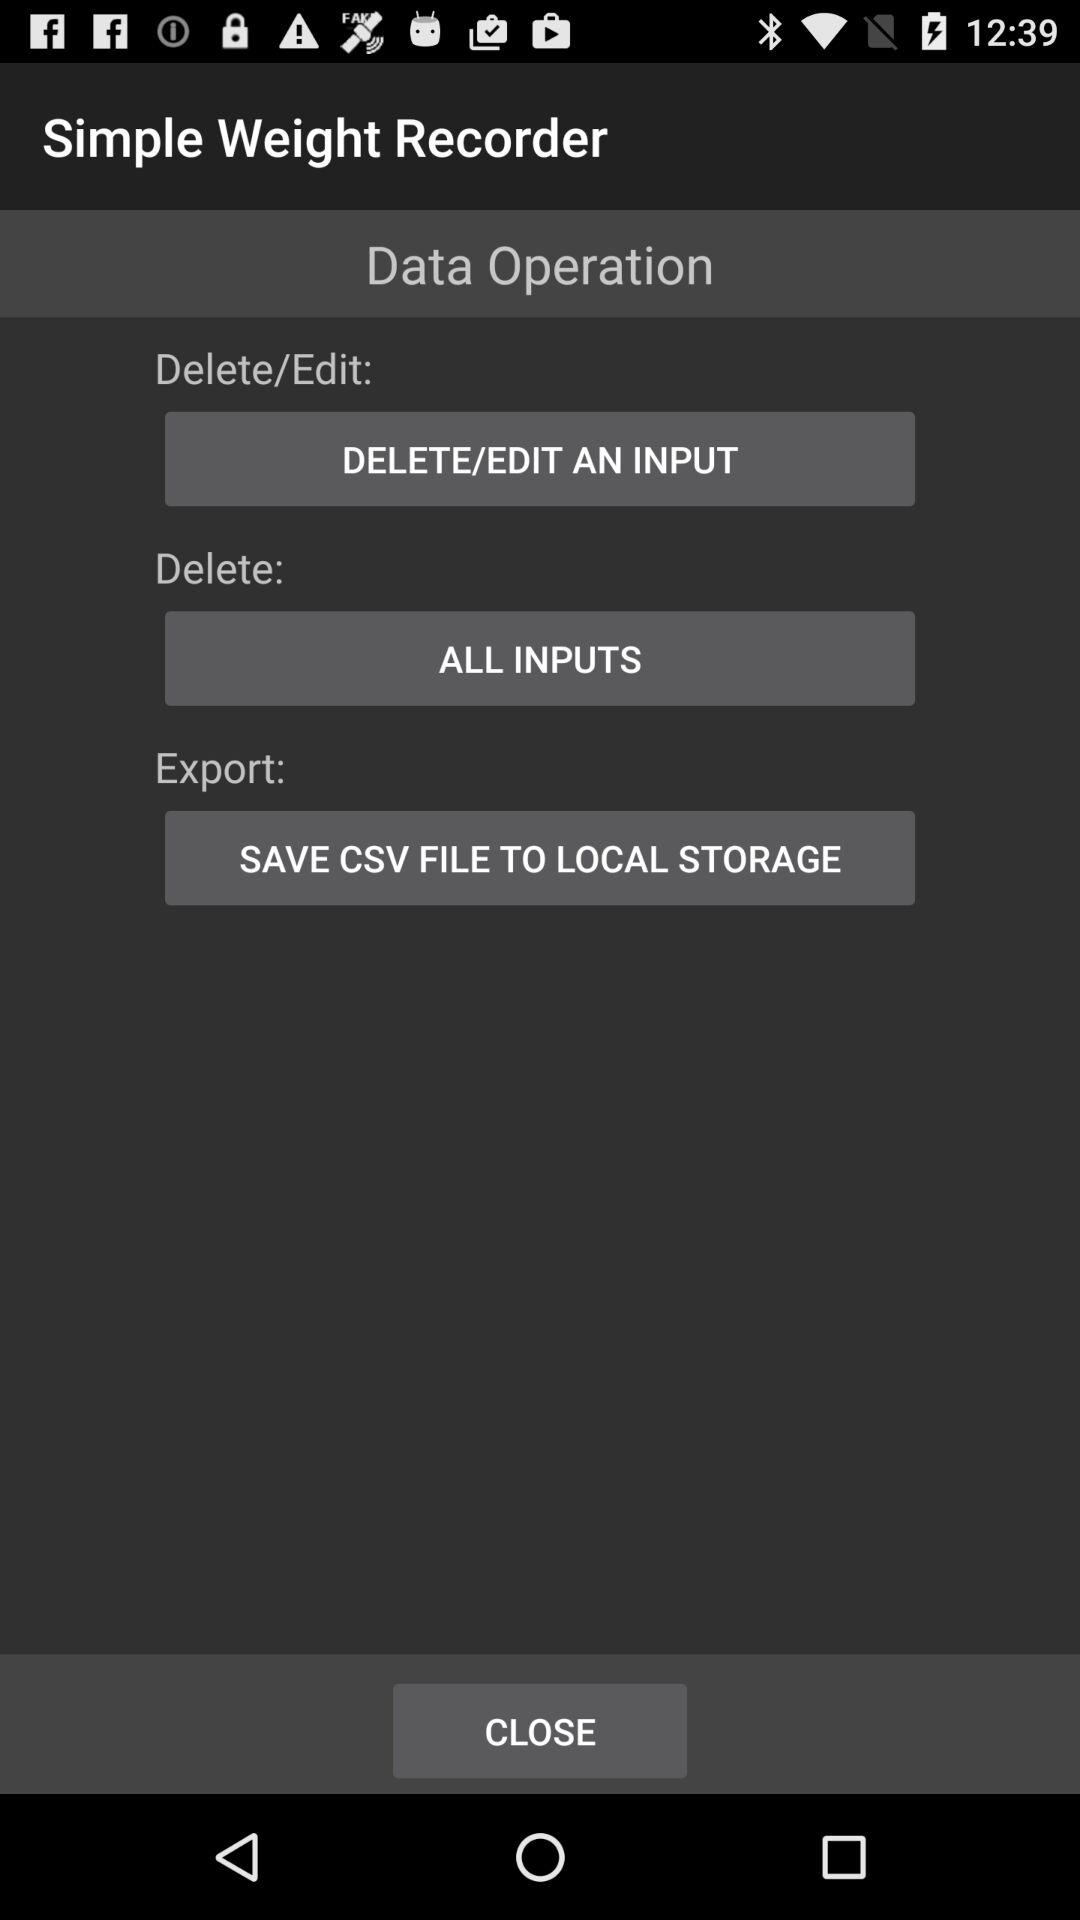What is the application name? The application name is "Simple Weight Recorder". 